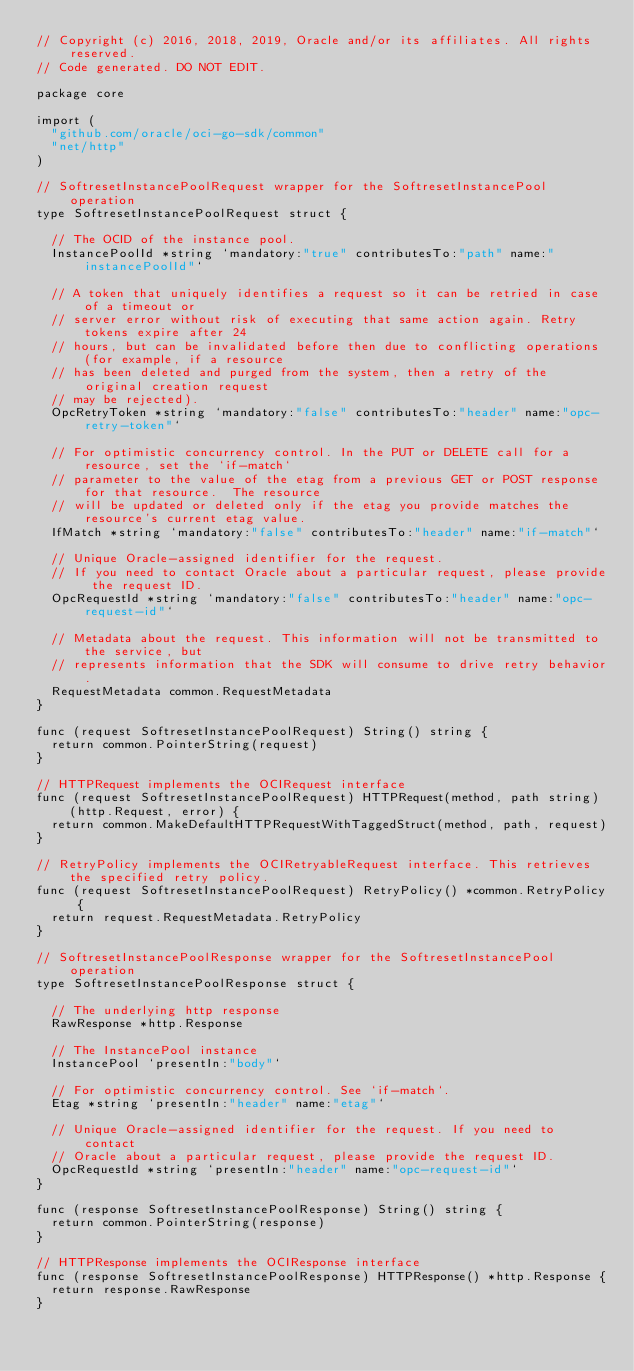Convert code to text. <code><loc_0><loc_0><loc_500><loc_500><_Go_>// Copyright (c) 2016, 2018, 2019, Oracle and/or its affiliates. All rights reserved.
// Code generated. DO NOT EDIT.

package core

import (
	"github.com/oracle/oci-go-sdk/common"
	"net/http"
)

// SoftresetInstancePoolRequest wrapper for the SoftresetInstancePool operation
type SoftresetInstancePoolRequest struct {

	// The OCID of the instance pool.
	InstancePoolId *string `mandatory:"true" contributesTo:"path" name:"instancePoolId"`

	// A token that uniquely identifies a request so it can be retried in case of a timeout or
	// server error without risk of executing that same action again. Retry tokens expire after 24
	// hours, but can be invalidated before then due to conflicting operations (for example, if a resource
	// has been deleted and purged from the system, then a retry of the original creation request
	// may be rejected).
	OpcRetryToken *string `mandatory:"false" contributesTo:"header" name:"opc-retry-token"`

	// For optimistic concurrency control. In the PUT or DELETE call for a resource, set the `if-match`
	// parameter to the value of the etag from a previous GET or POST response for that resource.  The resource
	// will be updated or deleted only if the etag you provide matches the resource's current etag value.
	IfMatch *string `mandatory:"false" contributesTo:"header" name:"if-match"`

	// Unique Oracle-assigned identifier for the request.
	// If you need to contact Oracle about a particular request, please provide the request ID.
	OpcRequestId *string `mandatory:"false" contributesTo:"header" name:"opc-request-id"`

	// Metadata about the request. This information will not be transmitted to the service, but
	// represents information that the SDK will consume to drive retry behavior.
	RequestMetadata common.RequestMetadata
}

func (request SoftresetInstancePoolRequest) String() string {
	return common.PointerString(request)
}

// HTTPRequest implements the OCIRequest interface
func (request SoftresetInstancePoolRequest) HTTPRequest(method, path string) (http.Request, error) {
	return common.MakeDefaultHTTPRequestWithTaggedStruct(method, path, request)
}

// RetryPolicy implements the OCIRetryableRequest interface. This retrieves the specified retry policy.
func (request SoftresetInstancePoolRequest) RetryPolicy() *common.RetryPolicy {
	return request.RequestMetadata.RetryPolicy
}

// SoftresetInstancePoolResponse wrapper for the SoftresetInstancePool operation
type SoftresetInstancePoolResponse struct {

	// The underlying http response
	RawResponse *http.Response

	// The InstancePool instance
	InstancePool `presentIn:"body"`

	// For optimistic concurrency control. See `if-match`.
	Etag *string `presentIn:"header" name:"etag"`

	// Unique Oracle-assigned identifier for the request. If you need to contact
	// Oracle about a particular request, please provide the request ID.
	OpcRequestId *string `presentIn:"header" name:"opc-request-id"`
}

func (response SoftresetInstancePoolResponse) String() string {
	return common.PointerString(response)
}

// HTTPResponse implements the OCIResponse interface
func (response SoftresetInstancePoolResponse) HTTPResponse() *http.Response {
	return response.RawResponse
}
</code> 